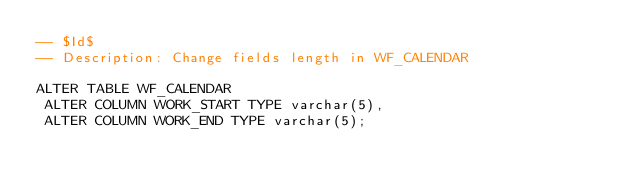Convert code to text. <code><loc_0><loc_0><loc_500><loc_500><_SQL_>-- $Id$
-- Description: Change fields length in WF_CALENDAR

ALTER TABLE WF_CALENDAR
 ALTER COLUMN WORK_START TYPE varchar(5),
 ALTER COLUMN WORK_END TYPE varchar(5);</code> 